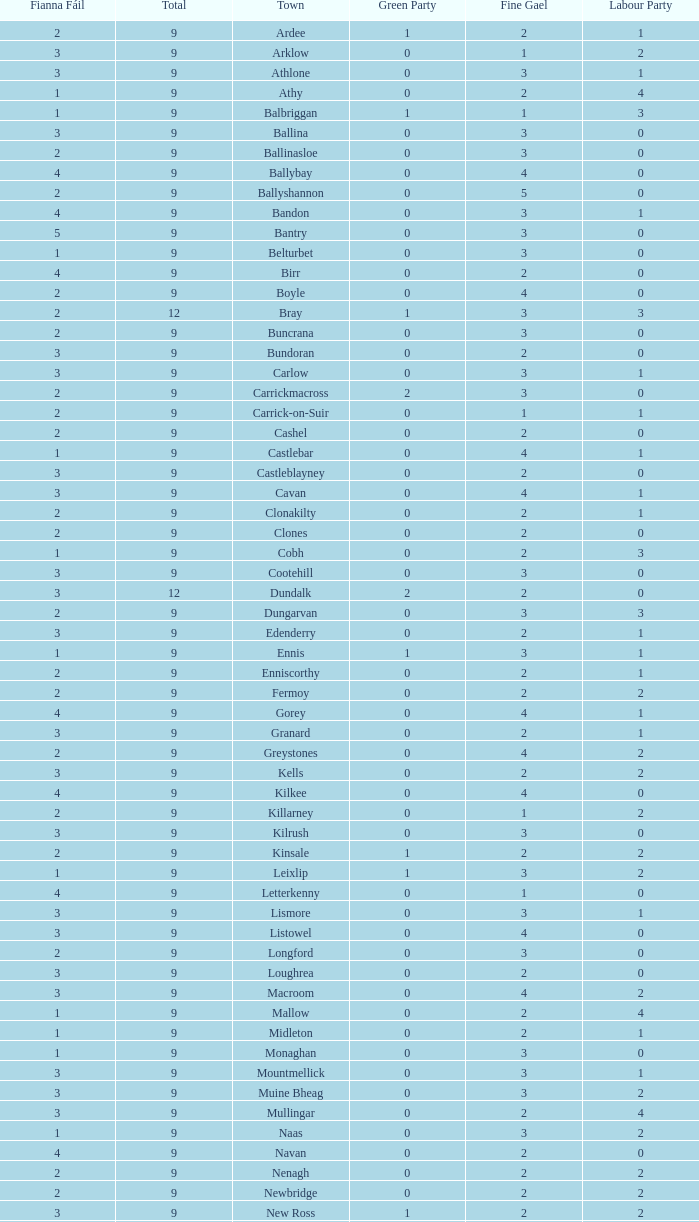How many are in the labour party of a fianna fail of 3 with a total exceeding 9 and over 2 in the green party? None. 